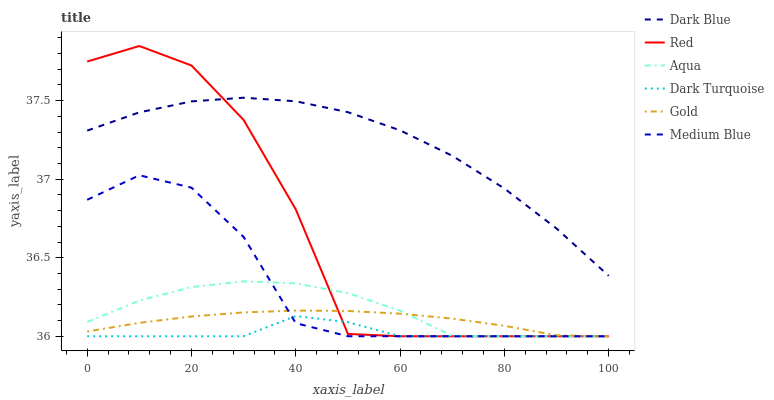Does Dark Turquoise have the minimum area under the curve?
Answer yes or no. Yes. Does Dark Blue have the maximum area under the curve?
Answer yes or no. Yes. Does Aqua have the minimum area under the curve?
Answer yes or no. No. Does Aqua have the maximum area under the curve?
Answer yes or no. No. Is Gold the smoothest?
Answer yes or no. Yes. Is Red the roughest?
Answer yes or no. Yes. Is Aqua the smoothest?
Answer yes or no. No. Is Aqua the roughest?
Answer yes or no. No. Does Gold have the lowest value?
Answer yes or no. Yes. Does Dark Blue have the lowest value?
Answer yes or no. No. Does Red have the highest value?
Answer yes or no. Yes. Does Aqua have the highest value?
Answer yes or no. No. Is Dark Turquoise less than Dark Blue?
Answer yes or no. Yes. Is Dark Blue greater than Medium Blue?
Answer yes or no. Yes. Does Dark Turquoise intersect Aqua?
Answer yes or no. Yes. Is Dark Turquoise less than Aqua?
Answer yes or no. No. Is Dark Turquoise greater than Aqua?
Answer yes or no. No. Does Dark Turquoise intersect Dark Blue?
Answer yes or no. No. 